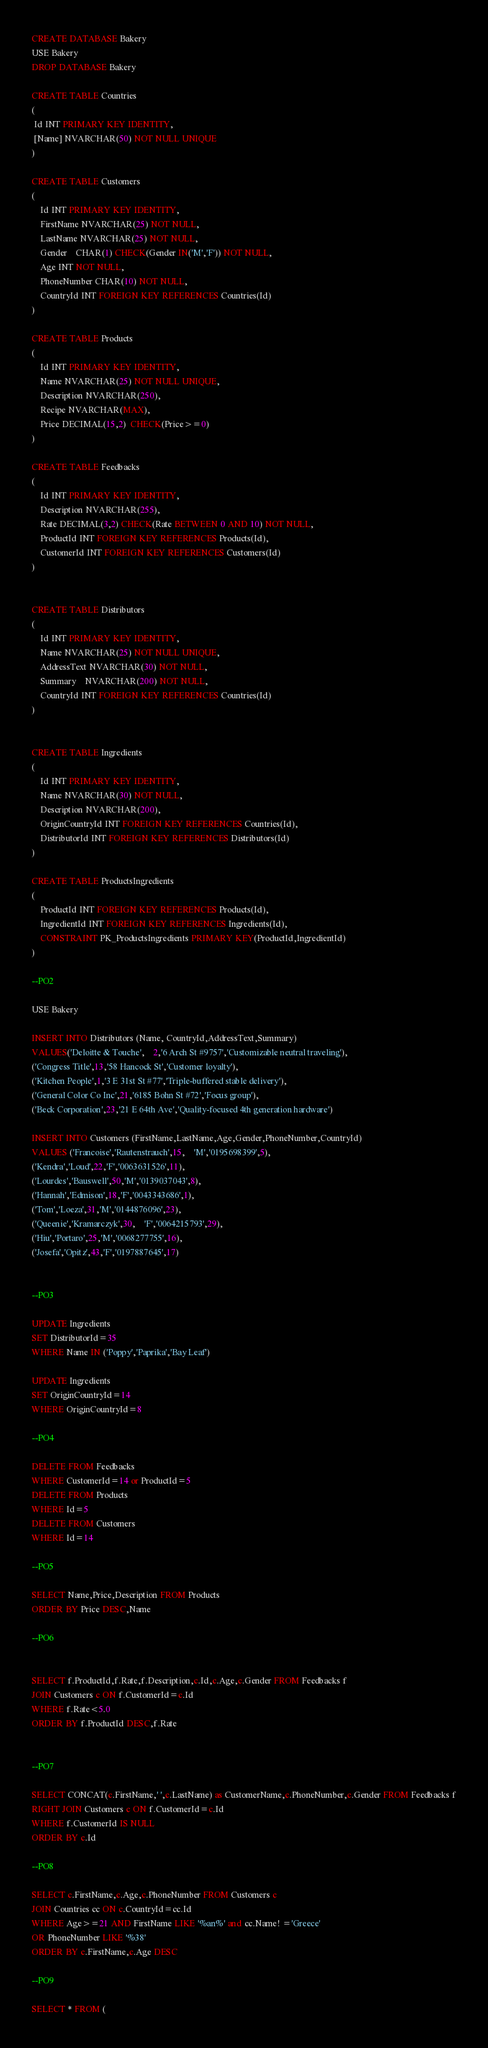<code> <loc_0><loc_0><loc_500><loc_500><_SQL_>

CREATE DATABASE Bakery
USE Bakery
DROP DATABASE Bakery

CREATE TABLE Countries
(
 Id INT PRIMARY KEY IDENTITY,
 [Name] NVARCHAR(50) NOT NULL UNIQUE
)

CREATE TABLE Customers
(
	Id INT PRIMARY KEY IDENTITY,
	FirstName NVARCHAR(25) NOT NULL,
	LastName NVARCHAR(25) NOT NULL,
	Gender	CHAR(1) CHECK(Gender IN('M','F')) NOT NULL,
	Age INT NOT NULL,
	PhoneNumber CHAR(10) NOT NULL,
	CountryId INT FOREIGN KEY REFERENCES Countries(Id)
)

CREATE TABLE Products
(
	Id INT PRIMARY KEY IDENTITY,
	Name NVARCHAR(25) NOT NULL UNIQUE,
	Description NVARCHAR(250),
	Recipe NVARCHAR(MAX),
	Price DECIMAL(15,2)  CHECK(Price>=0)
)

CREATE TABLE Feedbacks
(
	Id INT PRIMARY KEY IDENTITY,
	Description NVARCHAR(255),
	Rate DECIMAL(3,2) CHECK(Rate BETWEEN 0 AND 10) NOT NULL,
	ProductId INT FOREIGN KEY REFERENCES Products(Id),
	CustomerId INT FOREIGN KEY REFERENCES Customers(Id)
)


CREATE TABLE Distributors
(
	Id INT PRIMARY KEY IDENTITY,
	Name NVARCHAR(25) NOT NULL UNIQUE,
	AddressText NVARCHAR(30) NOT NULL,	
	Summary	NVARCHAR(200) NOT NULL,	
	CountryId INT FOREIGN KEY REFERENCES Countries(Id)
)


CREATE TABLE Ingredients
(
	Id INT PRIMARY KEY IDENTITY,
	Name NVARCHAR(30) NOT NULL,
	Description NVARCHAR(200),
	OriginCountryId INT FOREIGN KEY REFERENCES Countries(Id),
	DistributorId INT FOREIGN KEY REFERENCES Distributors(Id)
)

CREATE TABLE ProductsIngredients
(
	ProductId INT FOREIGN KEY REFERENCES Products(Id),
	IngredientId INT FOREIGN KEY REFERENCES Ingredients(Id),
	CONSTRAINT PK_ProductsIngredients PRIMARY KEY(ProductId,IngredientId)
)

--PO2

USE Bakery

INSERT INTO Distributors (Name, CountryId,AddressText,Summary)
VALUES('Deloitte & Touche',	2,'6 Arch St #9757','Customizable neutral traveling'),
('Congress Title',13,'58 Hancock St','Customer loyalty'),
('Kitchen People',1,'3 E 31st St #77','Triple-buffered stable delivery'),
('General Color Co Inc',21,'6185 Bohn St #72','Focus group'),
('Beck Corporation',23,'21 E 64th Ave','Quality-focused 4th generation hardware')

INSERT INTO Customers (FirstName,LastName,Age,Gender,PhoneNumber,CountryId)
VALUES ('Francoise','Rautenstrauch',15,	'M','0195698399',5),
('Kendra','Loud',22,'F','0063631526',11),
('Lourdes','Bauswell',50,'M','0139037043',8),
('Hannah','Edmison',18,'F','0043343686',1),
('Tom','Loeza',31,'M','0144876096',23),
('Queenie','Kramarczyk',30,	'F','0064215793',29),
('Hiu','Portaro',25,'M','0068277755',16),
('Josefa','Opitz',43,'F','0197887645',17)


--PO3
    
UPDATE Ingredients
SET DistributorId=35
WHERE Name IN ('Poppy','Paprika','Bay Leaf')

UPDATE Ingredients
SET OriginCountryId=14
WHERE OriginCountryId=8

--PO4

DELETE FROM Feedbacks
WHERE CustomerId=14 or ProductId=5
DELETE FROM Products
WHERE Id=5
DELETE FROM Customers
WHERE Id=14

--PO5

SELECT Name,Price,Description FROM Products
ORDER BY Price DESC,Name

--PO6


SELECT f.ProductId,f.Rate,f.Description,c.Id,c.Age,c.Gender FROM Feedbacks f
JOIN Customers c ON f.CustomerId=c.Id
WHERE f.Rate<5.0
ORDER BY f.ProductId DESC,f.Rate


--PO7

SELECT CONCAT(c.FirstName,' ',c.LastName) as CustomerName,c.PhoneNumber,c.Gender FROM Feedbacks f
RIGHT JOIN Customers c ON f.CustomerId=c.Id
WHERE f.CustomerId IS NULL
ORDER BY c.Id

--PO8

SELECT c.FirstName,c.Age,c.PhoneNumber FROM Customers c
JOIN Countries cc ON c.CountryId=cc.Id
WHERE Age>=21 AND FirstName LIKE '%an%' and cc.Name! ='Greece' 
OR PhoneNumber LIKE '%38'
ORDER BY c.FirstName,c.Age DESC

--PO9

SELECT * FROM (</code> 